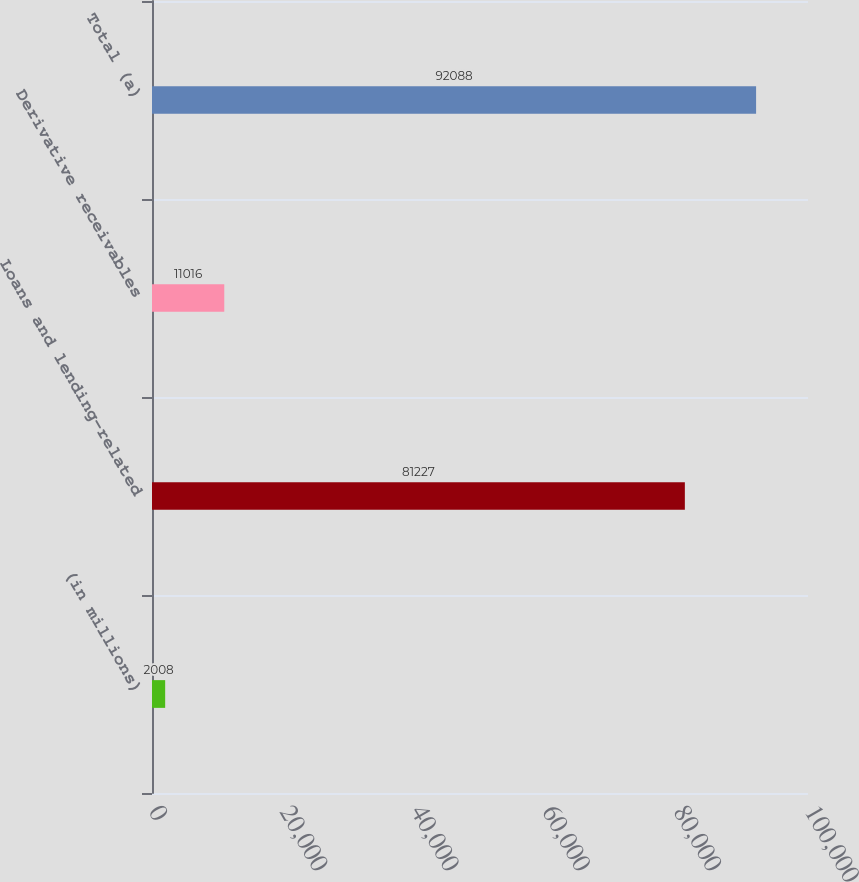Convert chart to OTSL. <chart><loc_0><loc_0><loc_500><loc_500><bar_chart><fcel>(in millions)<fcel>Loans and lending-related<fcel>Derivative receivables<fcel>Total (a)<nl><fcel>2008<fcel>81227<fcel>11016<fcel>92088<nl></chart> 